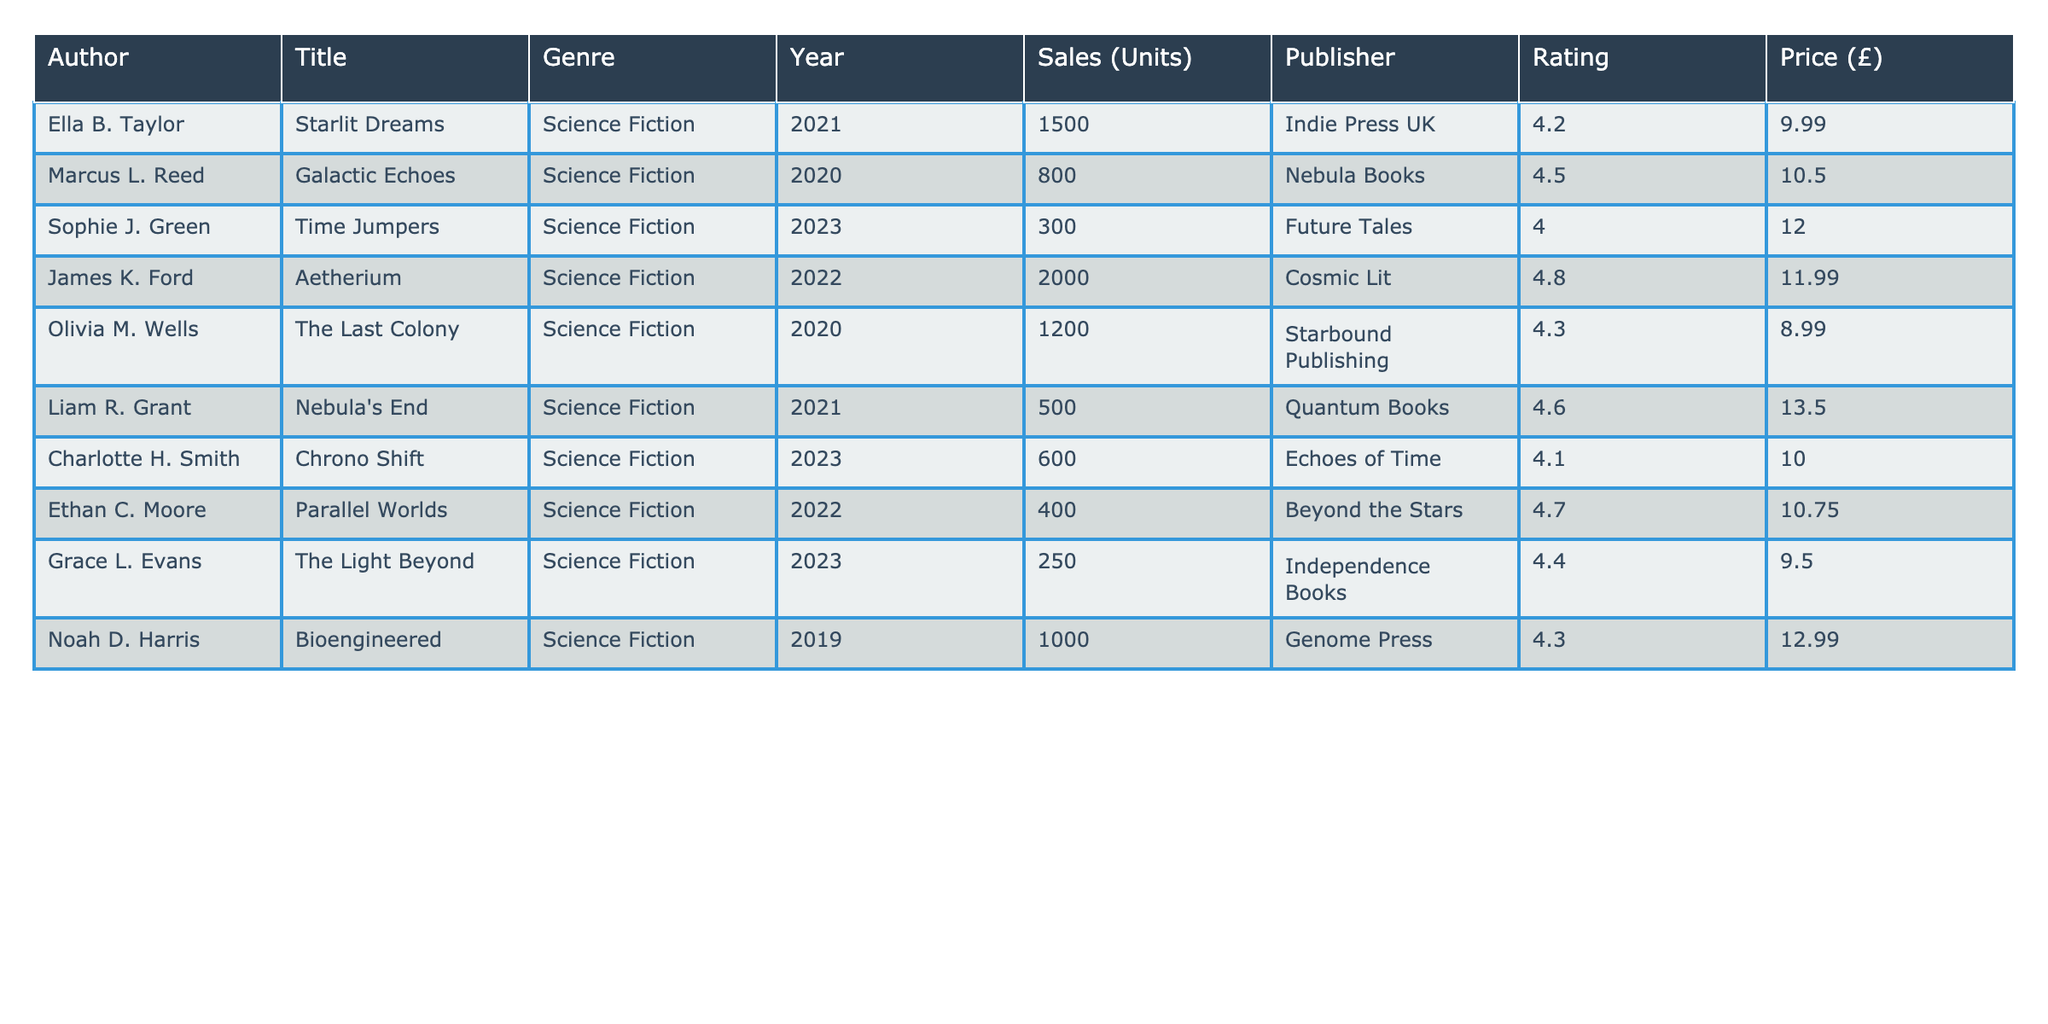What is the title of the book with the highest sales units? The table lists the titles and sales units of each book. By comparing the "Sales (Units)" column, "Aetherium" has the highest sales at 2000 units.
Answer: Aetherium Which author has the lowest sales and what is the number of units sold? By inspecting the "Sales (Units)" column, "Parallel Worlds" by Ethan C. Moore has the lowest sales at 400 units.
Answer: 400 What is the average rating of all the books listed in the table? To find the average rating, sum all the ratings (4.2 + 4.5 + 4.0 + 4.8 + 4.3 + 4.6 + 4.1 + 4.7 + 4.4 + 4.3) which is 44.9, and then divide by the number of books, which is 10. Thus, the average rating is 44.9 / 10 = 4.49.
Answer: 4.49 Is there an author with a rating of 4.8 or higher? By reviewing the "Rating" column, both James K. Ford's "Aetherium" (4.8) and Marcus L. Reed's "Galactic Echoes" (4.5) have ratings that meet or exceed 4.8. Therefore, the answer is yes.
Answer: Yes Which book published by "Quantum Books" has the highest rating? The table shows that "Nebula's End" by Liam R. Grant is published by "Quantum Books" and has a rating of 4.6. As it's the only entry from this publisher, it must be the highest rating.
Answer: Nebula's End How much difference is there in sales between the highest and lowest selling books? The highest selling book is "Aetherium" with sales of 2000 units, and the lowest is "Parallel Worlds" with 400 units. To find the difference, calculate 2000 - 400 = 1600. Therefore, the difference in sales is 1600 units.
Answer: 1600 What is the median price of the books listed? To find the median price, first, list the prices: £9.99, £10.50, £12.00, £11.99, £8.99, £13.50, £10.00, £10.75, £9.50, £12.99. When sorted, the middle values are £10.00 and £10.50, and the average of these two values (10.00 + 10.50) / 2 = 10.25. Thus, the median price is £10.25.
Answer: £10.25 Are there more books with sales over 1000 units or under 1000 units? There are 5 books with sales over 1000 units ("Aetherium", "The Last Colony", "Bioengineered", "Starlit Dreams", and "Galactic Echoes") and 5 books with sales under 1000 units ("Time Jumpers", "Nebula's End", "Parallel Worlds", and "Chrono Shift"). Thus, the counts are equal.
Answer: No What is the total number of units sold across all books? To find the total sales, sum the units sold for each book: 1500 + 800 + 300 + 2000 + 1200 + 500 + 600 + 400 + 250 + 1000 = 6150. Therefore, the total sales units is 6150.
Answer: 6150 Which genre has the highest average rating? Since all titles in the table are under the genre "Science Fiction", the average rating is the same for all. The average is calculated to be 4.49 based on the evaluation of all entries. Thus, "Science Fiction" has the highest average rating.
Answer: Science Fiction 